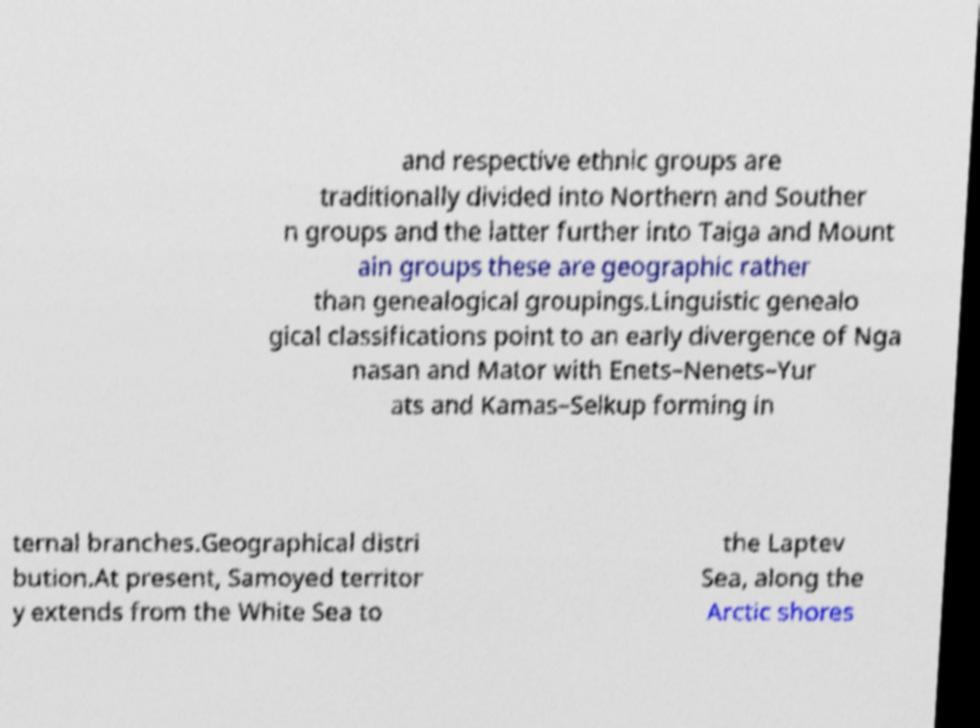Please read and relay the text visible in this image. What does it say? and respective ethnic groups are traditionally divided into Northern and Souther n groups and the latter further into Taiga and Mount ain groups these are geographic rather than genealogical groupings.Linguistic genealo gical classifications point to an early divergence of Nga nasan and Mator with Enets–Nenets–Yur ats and Kamas–Selkup forming in ternal branches.Geographical distri bution.At present, Samoyed territor y extends from the White Sea to the Laptev Sea, along the Arctic shores 